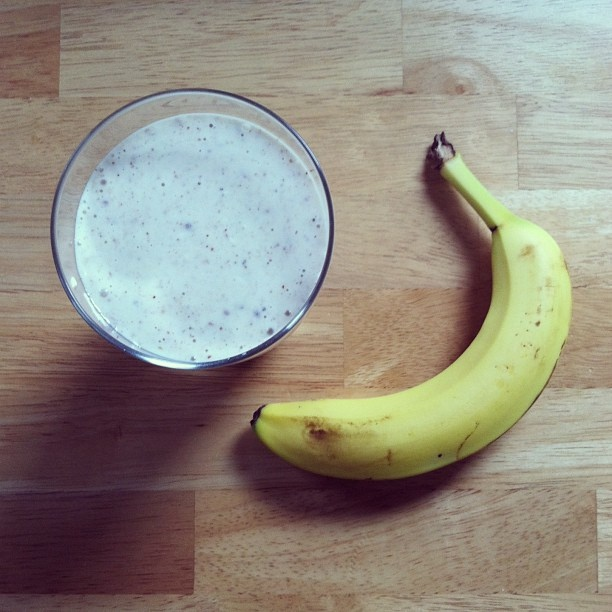Describe the objects in this image and their specific colors. I can see dining table in darkgray, gray, lightblue, and black tones, cup in gray, lightblue, and darkgray tones, bowl in gray, lightblue, and darkgray tones, and banana in gray, khaki, and olive tones in this image. 